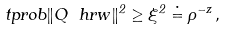<formula> <loc_0><loc_0><loc_500><loc_500>\ t p r o b { \| Q \ h r w \| ^ { 2 } \geq \xi ^ { 2 } } \doteq \rho ^ { - z } \, ,</formula> 